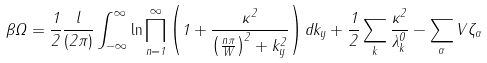<formula> <loc_0><loc_0><loc_500><loc_500>\beta \Omega = \frac { 1 } { 2 } \frac { l } { ( 2 \pi ) } \int _ { - \infty } ^ { \infty } \ln \prod _ { n = 1 } ^ { \infty } \left ( 1 + \frac { \kappa ^ { 2 } } { \left ( \frac { n \pi } { W } \right ) ^ { 2 } + k _ { y } ^ { 2 } } \right ) d k _ { y } + \frac { 1 } { 2 } \sum _ { k } \frac { \kappa ^ { 2 } } { \lambda _ { k } ^ { 0 } } - \sum _ { \alpha } V \zeta _ { \alpha }</formula> 